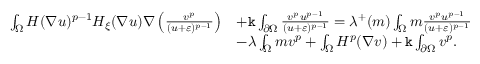Convert formula to latex. <formula><loc_0><loc_0><loc_500><loc_500>\begin{array} { r l } { \int _ { \Omega } H ( \nabla u ) ^ { p - 1 } H _ { \xi } ( \nabla u ) \nabla \left ( \frac { v ^ { p } } { ( u + \varepsilon ) ^ { p - 1 } } \right ) } & { + \mathtt k \int _ { \partial \Omega } \frac { v ^ { p } u ^ { p - 1 } } { ( u + \varepsilon ) ^ { p - 1 } } = \lambda ^ { + } ( m ) \int _ { \Omega } m \frac { v ^ { p } u ^ { p - 1 } } { ( u + \varepsilon ) ^ { p - 1 } } } \\ & { - \lambda \int _ { \Omega } m v ^ { p } + \int _ { \Omega } H ^ { p } ( \nabla v ) + \mathtt k \int _ { \partial \Omega } v ^ { p } . } \end{array}</formula> 